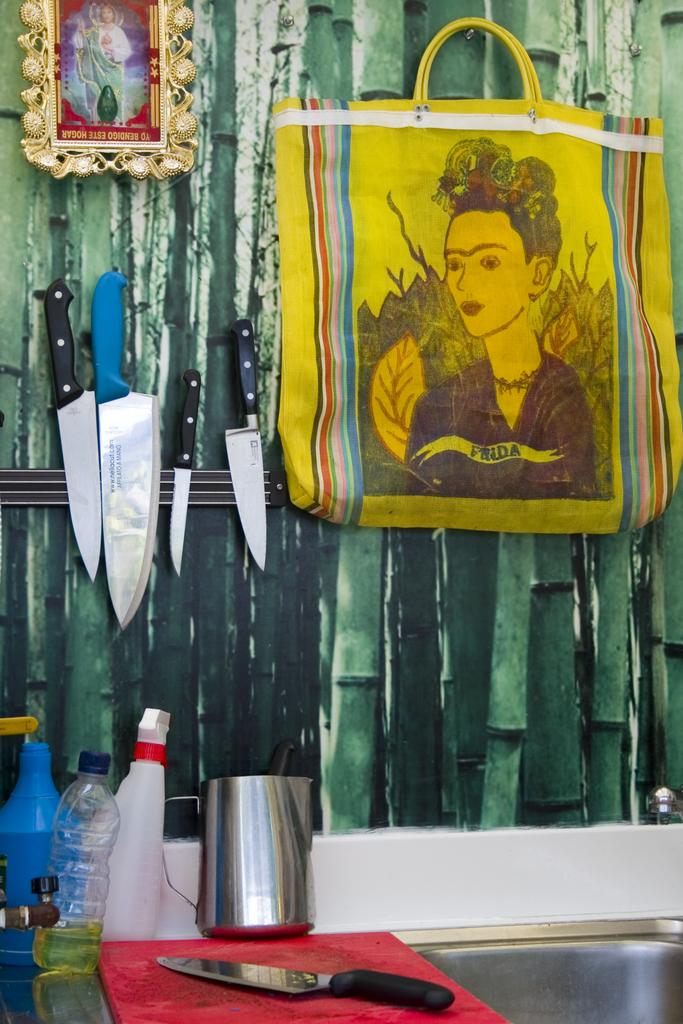What object in the image is used for displaying photos? There is a photo frame in the image. What object in the image is used for carrying items? There is a bag in the image. What object in the image is used for cutting? There is a knife in the image, and it is attached to the wall. What object in the image is used for drinking water? There is a water bottle in the image. What object in the image is used for cutting safely? There is a knife cutter in the image. How many snakes are slithering on the stove in the image? There are no snakes or stoves present in the image. What is located in the middle of the image? The provided facts do not specify any object or subject being in the middle of the image. 